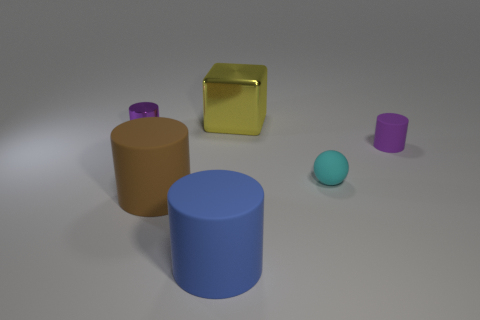Subtract all tiny purple matte cylinders. How many cylinders are left? 3 Subtract 1 balls. How many balls are left? 0 Add 2 rubber cylinders. How many objects exist? 8 Subtract all cylinders. How many objects are left? 2 Add 3 big blue rubber objects. How many big blue rubber objects are left? 4 Add 3 metal things. How many metal things exist? 5 Subtract all purple cylinders. How many cylinders are left? 2 Subtract 1 cyan spheres. How many objects are left? 5 Subtract all blue spheres. Subtract all blue cylinders. How many spheres are left? 1 Subtract all brown balls. How many gray cubes are left? 0 